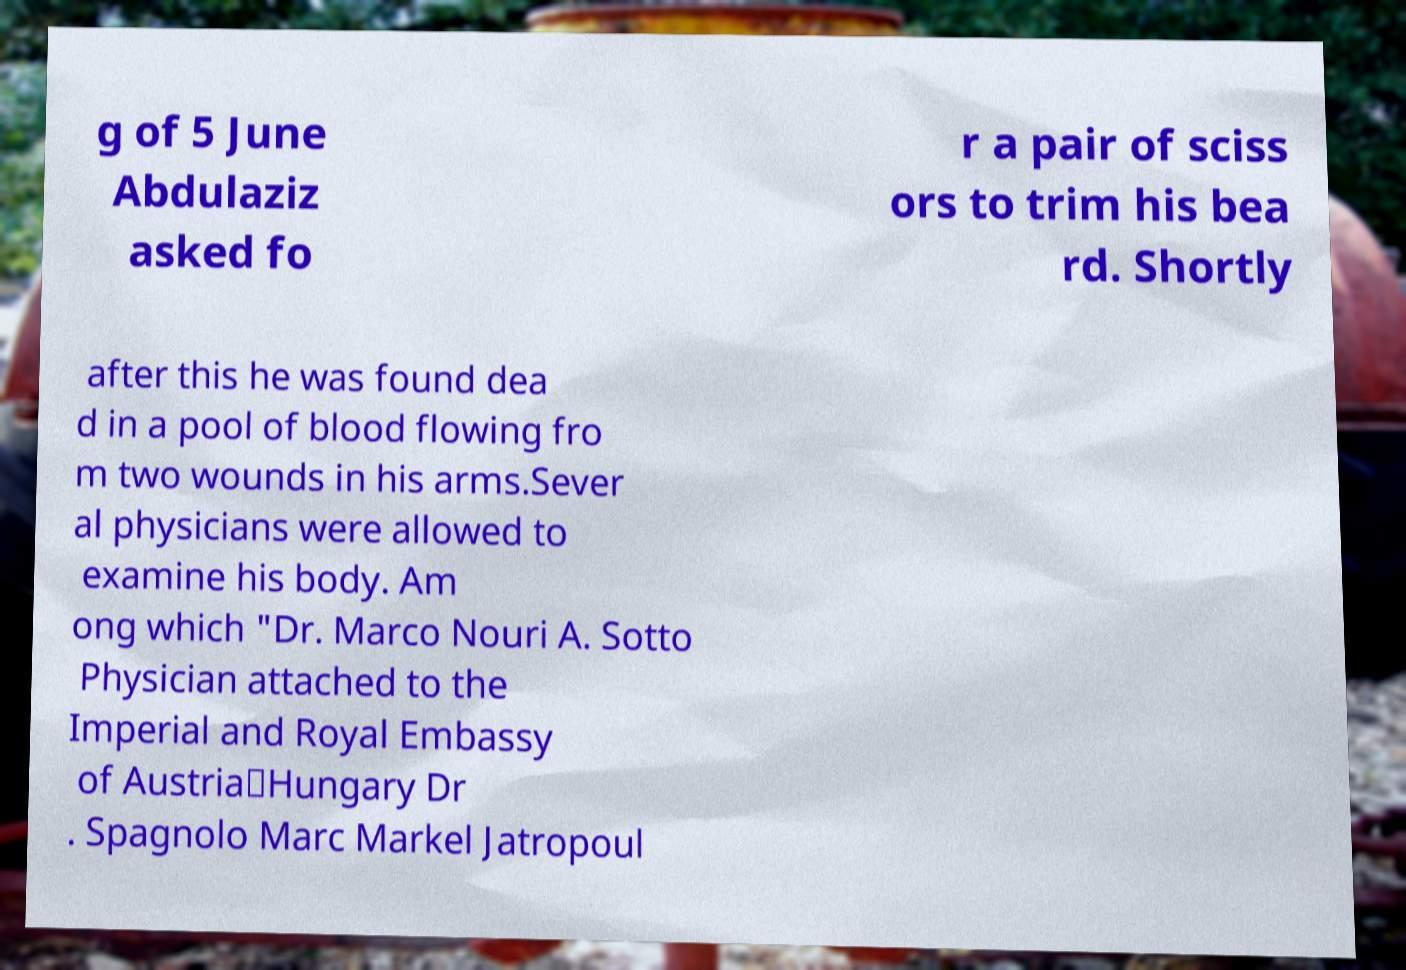Please read and relay the text visible in this image. What does it say? g of 5 June Abdulaziz asked fo r a pair of sciss ors to trim his bea rd. Shortly after this he was found dea d in a pool of blood flowing fro m two wounds in his arms.Sever al physicians were allowed to examine his body. Am ong which "Dr. Marco Nouri A. Sotto Physician attached to the Imperial and Royal Embassy of Austria‐Hungary Dr . Spagnolo Marc Markel Jatropoul 